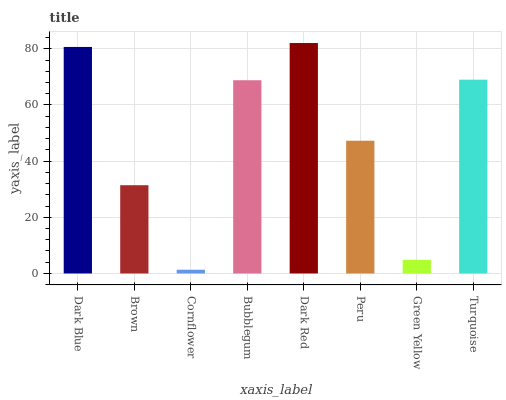Is Cornflower the minimum?
Answer yes or no. Yes. Is Dark Red the maximum?
Answer yes or no. Yes. Is Brown the minimum?
Answer yes or no. No. Is Brown the maximum?
Answer yes or no. No. Is Dark Blue greater than Brown?
Answer yes or no. Yes. Is Brown less than Dark Blue?
Answer yes or no. Yes. Is Brown greater than Dark Blue?
Answer yes or no. No. Is Dark Blue less than Brown?
Answer yes or no. No. Is Bubblegum the high median?
Answer yes or no. Yes. Is Peru the low median?
Answer yes or no. Yes. Is Dark Blue the high median?
Answer yes or no. No. Is Brown the low median?
Answer yes or no. No. 